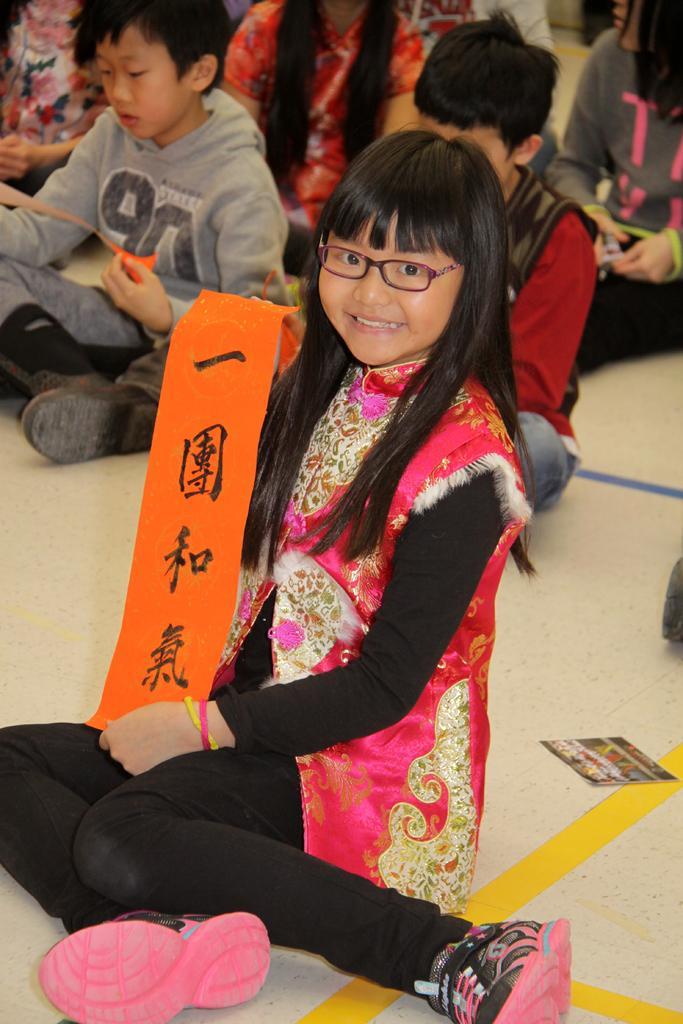Can you describe this image briefly? In the foreground of the picture we can see a girl holding a red ribbon. In the background there are kids sitting on the floor. On the right we can see a photograph. 